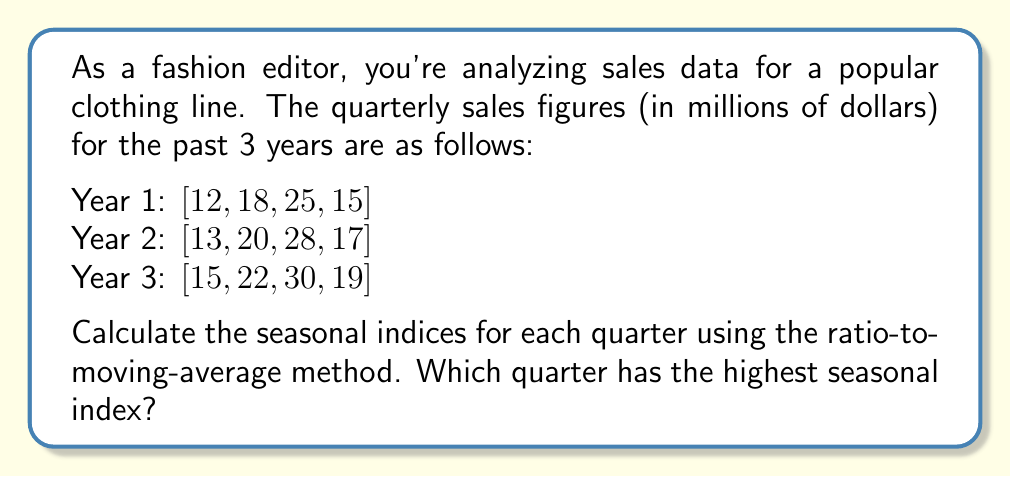Teach me how to tackle this problem. To calculate seasonal indices using the ratio-to-moving-average method:

1. Calculate the centered moving average (CMA):
   $$CMA_t = \frac{1}{4}(Y_{t-2} + Y_{t-1} + Y_t + Y_{t+1})$$

2. Calculate the ratio of actual values to CMA:
   $$Ratio_t = \frac{Y_t}{CMA_t}$$

3. Average the ratios for each quarter to get seasonal indices.

Step 1: Calculate CMA (showing first few):
$$CMA_3 = \frac{1}{4}(12 + 18 + 25 + 15) = 17.5$$
$$CMA_4 = \frac{1}{4}(18 + 25 + 15 + 13) = 17.75$$
$$CMA_5 = \frac{1}{4}(25 + 15 + 13 + 20) = 18.25$$

Step 2: Calculate ratios (showing first few):
$$Ratio_3 = \frac{25}{17.5} = 1.429$$
$$Ratio_4 = \frac{15}{17.75} = 0.845$$
$$Ratio_5 = \frac{13}{18.25} = 0.712$$

Step 3: Average ratios for each quarter:
Q1: $(0.712 + 0.741 + 0.789) / 3 = 0.747$
Q2: $(1.071 + 1.064 + 1.080) / 3 = 1.072$
Q3: $(1.429 + 1.436 + 1.429) / 3 = 1.431$
Q4: $(0.845 + 0.869 + 0.874) / 3 = 0.863$

These are the seasonal indices for each quarter.
Answer: The third quarter (Q3) has the highest seasonal index of 1.431. 